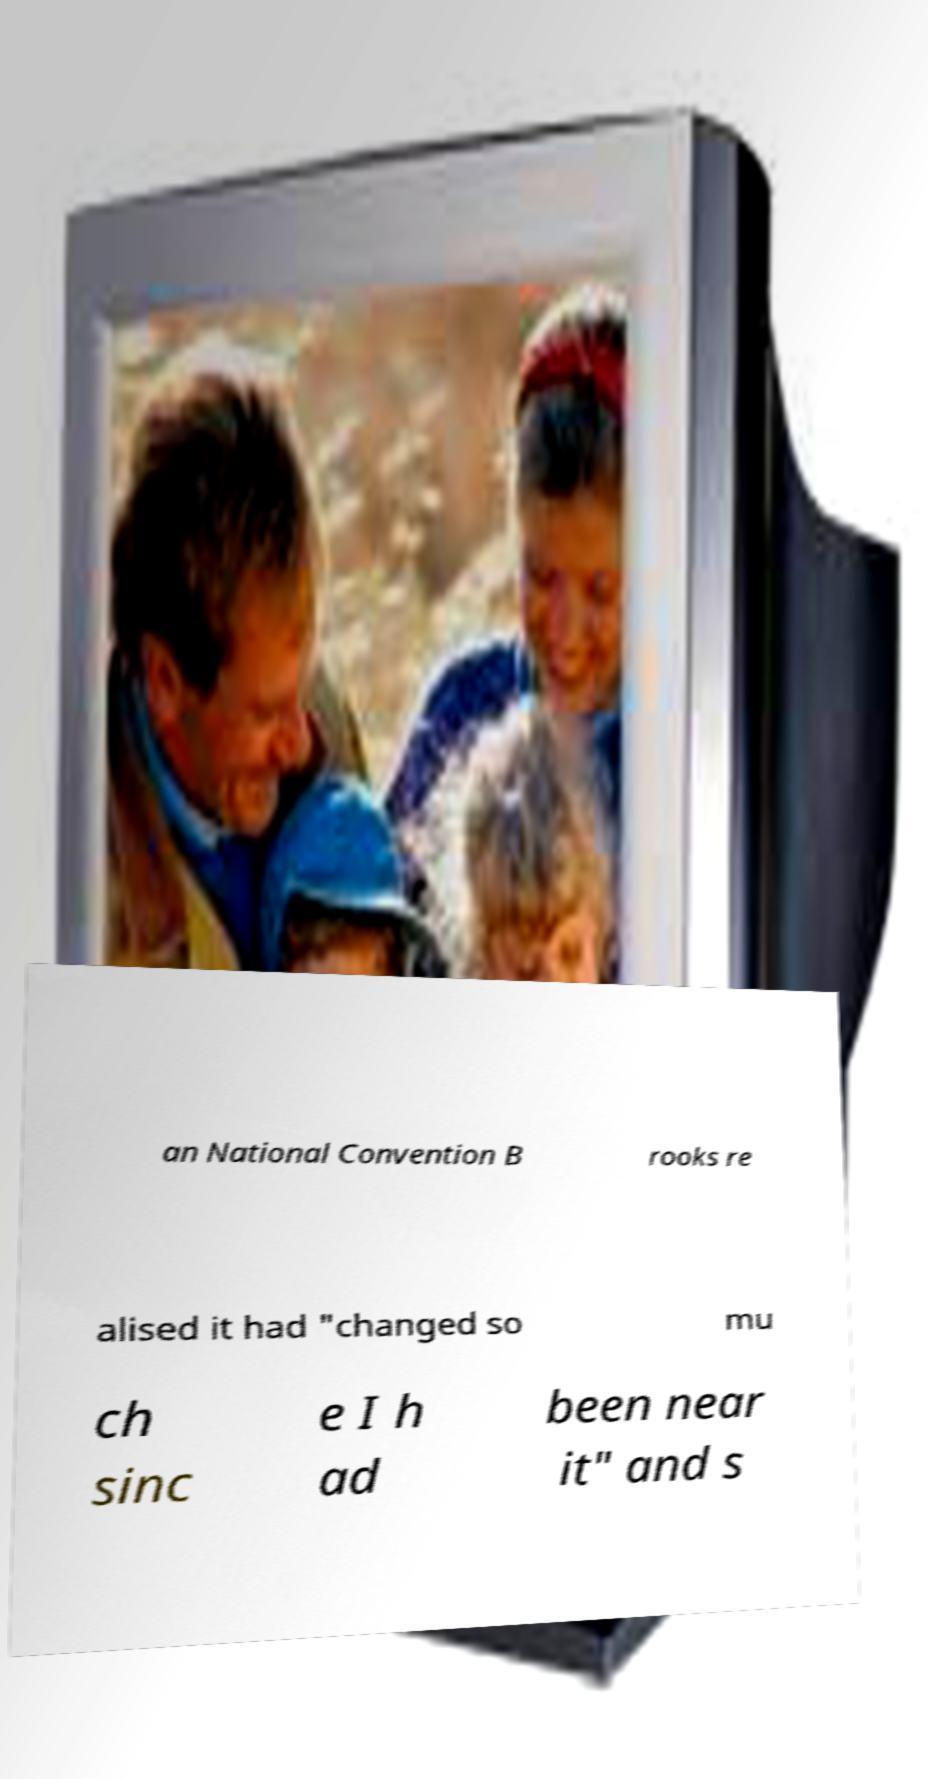Could you assist in decoding the text presented in this image and type it out clearly? an National Convention B rooks re alised it had "changed so mu ch sinc e I h ad been near it" and s 